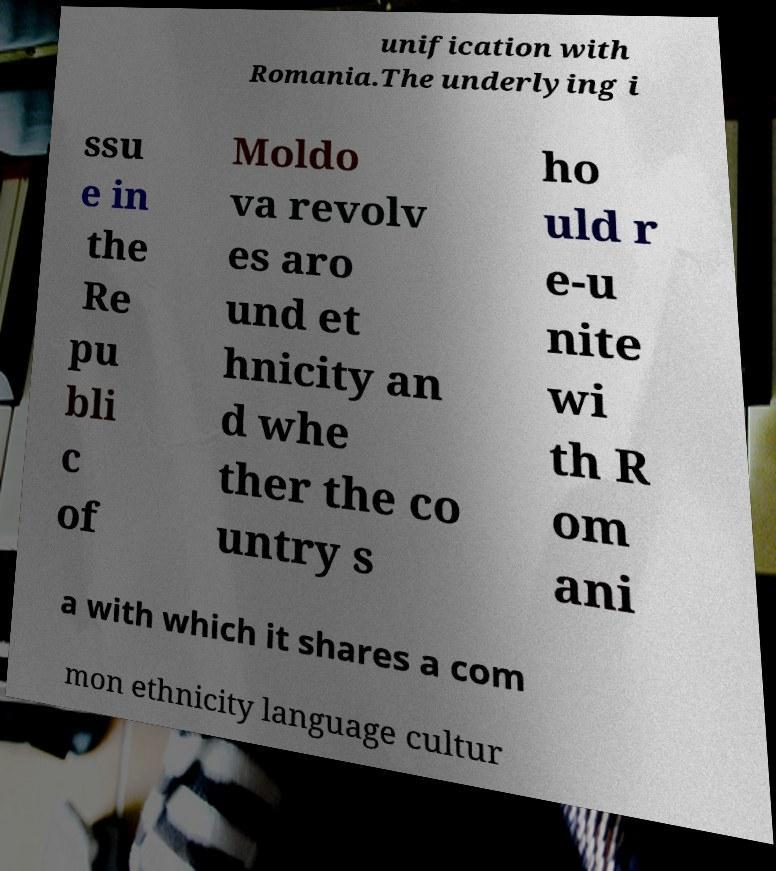What messages or text are displayed in this image? I need them in a readable, typed format. unification with Romania.The underlying i ssu e in the Re pu bli c of Moldo va revolv es aro und et hnicity an d whe ther the co untry s ho uld r e-u nite wi th R om ani a with which it shares a com mon ethnicity language cultur 